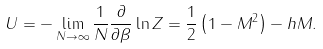<formula> <loc_0><loc_0><loc_500><loc_500>U = - \lim _ { N \rightarrow \infty } \frac { 1 } { N } \frac { \partial } { \partial \beta } \ln Z = \frac { 1 } { 2 } \left ( 1 - M ^ { 2 } \right ) - h M .</formula> 